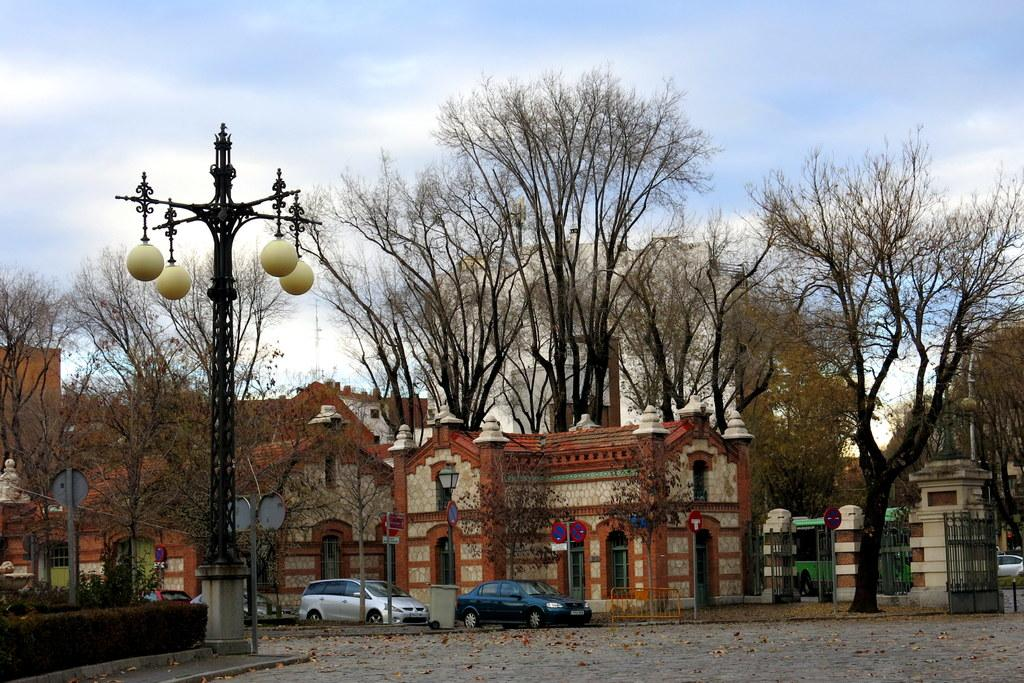What structures can be seen in the image? There are poles, lights, and vehicles in the image. What can be found in the background of the image? In the background, there are sign boards, trees, and buildings. What type of cake is being served on the street in the image? There is no cake or street present in the image; it features poles, lights, vehicles, sign boards, trees, and buildings. 